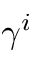Convert formula to latex. <formula><loc_0><loc_0><loc_500><loc_500>\gamma ^ { i }</formula> 